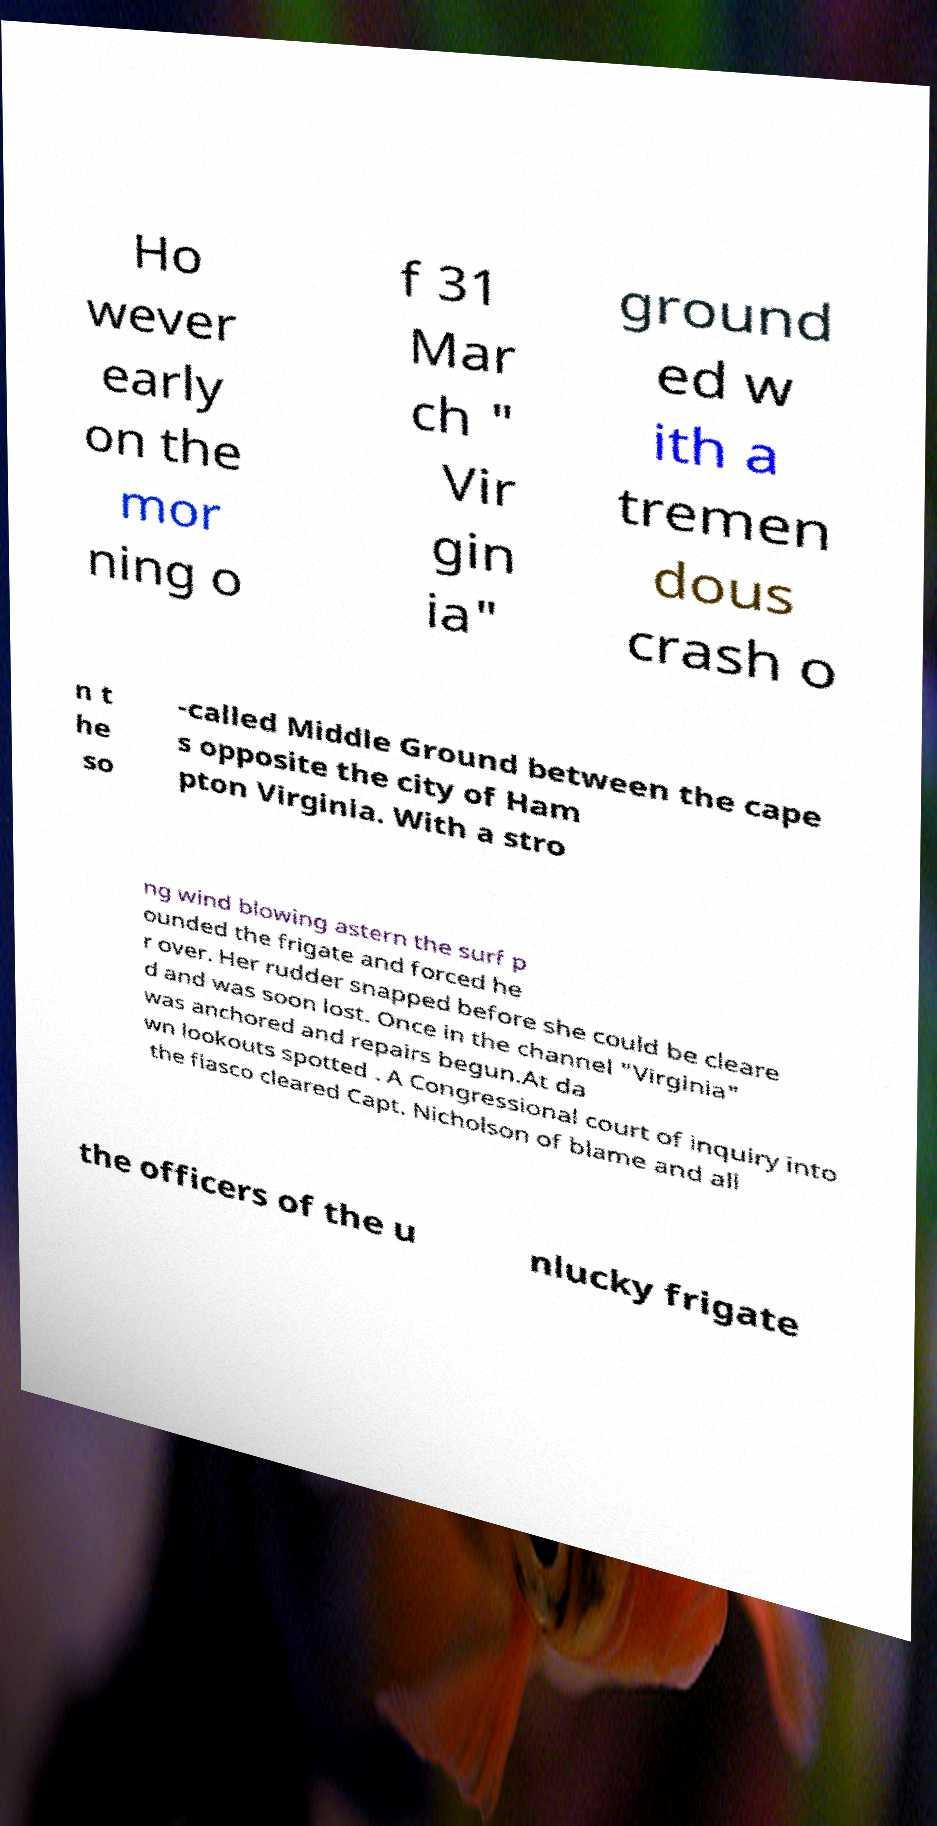What messages or text are displayed in this image? I need them in a readable, typed format. Ho wever early on the mor ning o f 31 Mar ch " Vir gin ia" ground ed w ith a tremen dous crash o n t he so -called Middle Ground between the cape s opposite the city of Ham pton Virginia. With a stro ng wind blowing astern the surf p ounded the frigate and forced he r over. Her rudder snapped before she could be cleare d and was soon lost. Once in the channel "Virginia" was anchored and repairs begun.At da wn lookouts spotted . A Congressional court of inquiry into the fiasco cleared Capt. Nicholson of blame and all the officers of the u nlucky frigate 